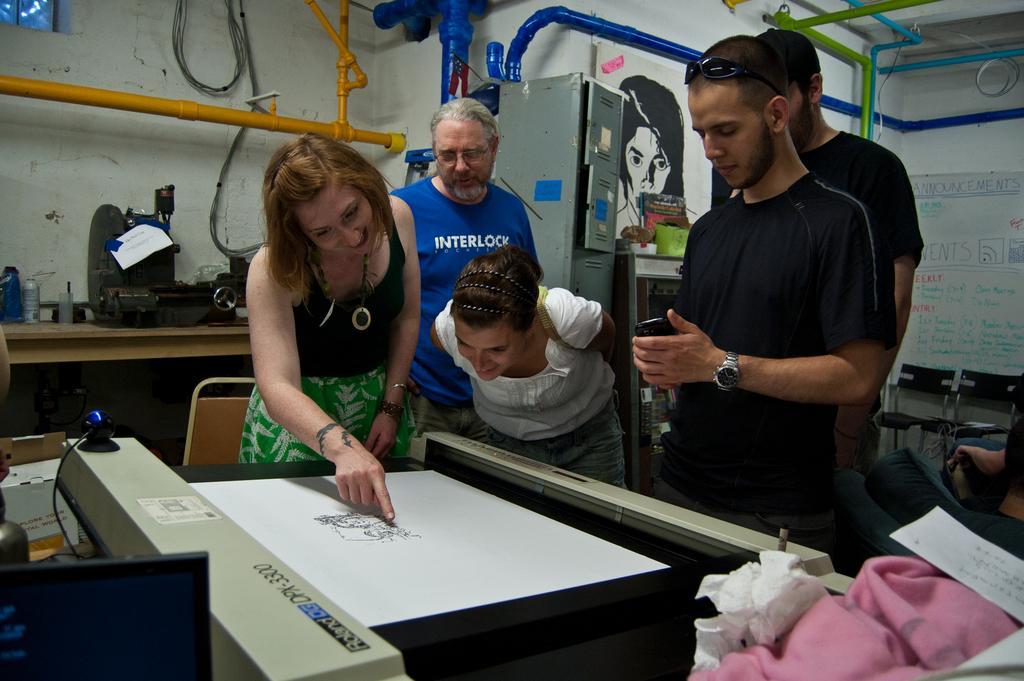How would you summarize this image in a sentence or two? There are group of people looking at the paper which has some image on it and there are objects around them. 